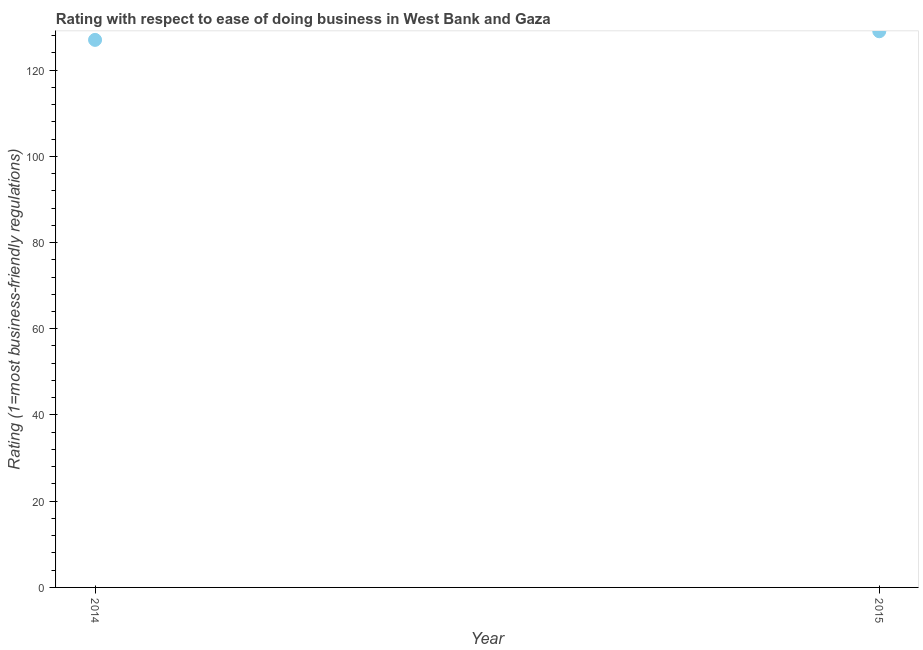What is the ease of doing business index in 2015?
Offer a terse response. 129. Across all years, what is the maximum ease of doing business index?
Your answer should be compact. 129. Across all years, what is the minimum ease of doing business index?
Keep it short and to the point. 127. In which year was the ease of doing business index maximum?
Offer a terse response. 2015. What is the sum of the ease of doing business index?
Make the answer very short. 256. What is the difference between the ease of doing business index in 2014 and 2015?
Offer a terse response. -2. What is the average ease of doing business index per year?
Your response must be concise. 128. What is the median ease of doing business index?
Keep it short and to the point. 128. What is the ratio of the ease of doing business index in 2014 to that in 2015?
Your answer should be very brief. 0.98. In how many years, is the ease of doing business index greater than the average ease of doing business index taken over all years?
Provide a succinct answer. 1. Does the ease of doing business index monotonically increase over the years?
Your answer should be very brief. Yes. How many years are there in the graph?
Offer a very short reply. 2. What is the difference between two consecutive major ticks on the Y-axis?
Your answer should be compact. 20. Are the values on the major ticks of Y-axis written in scientific E-notation?
Your answer should be very brief. No. What is the title of the graph?
Make the answer very short. Rating with respect to ease of doing business in West Bank and Gaza. What is the label or title of the X-axis?
Make the answer very short. Year. What is the label or title of the Y-axis?
Keep it short and to the point. Rating (1=most business-friendly regulations). What is the Rating (1=most business-friendly regulations) in 2014?
Offer a very short reply. 127. What is the Rating (1=most business-friendly regulations) in 2015?
Give a very brief answer. 129. What is the difference between the Rating (1=most business-friendly regulations) in 2014 and 2015?
Provide a succinct answer. -2. 